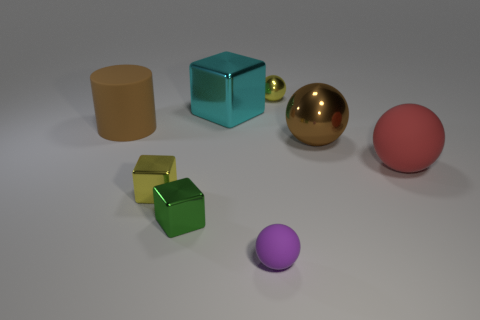Is there anything else that has the same size as the red matte ball?
Ensure brevity in your answer.  Yes. What number of small purple things are the same shape as the brown matte thing?
Ensure brevity in your answer.  0. What size is the matte thing right of the large brown object that is to the right of the yellow metal thing that is behind the big red ball?
Make the answer very short. Large. How many red things are tiny metallic cylinders or matte spheres?
Make the answer very short. 1. Do the small metal thing behind the big red object and the brown matte thing have the same shape?
Offer a terse response. No. Is the number of metallic things that are behind the green object greater than the number of small yellow blocks?
Keep it short and to the point. Yes. What number of yellow balls have the same size as the red sphere?
Keep it short and to the point. 0. What size is the sphere that is the same color as the big cylinder?
Your response must be concise. Large. What number of objects are cylinders or shiny things that are on the left side of the cyan cube?
Ensure brevity in your answer.  3. There is a metal thing that is in front of the large rubber cylinder and behind the red thing; what color is it?
Make the answer very short. Brown. 